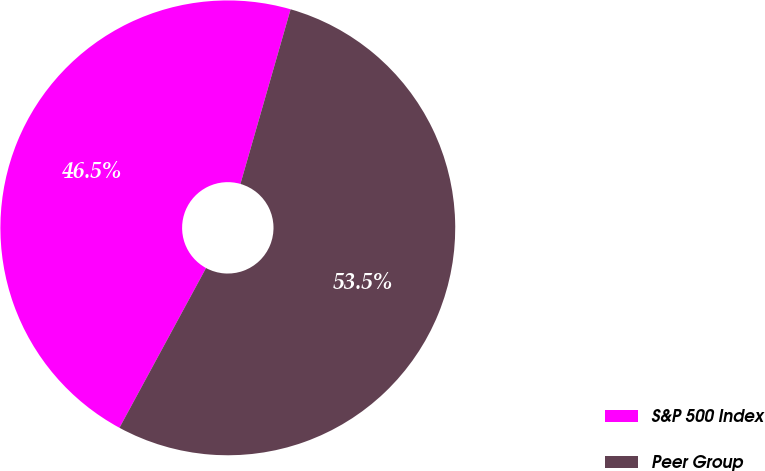Convert chart to OTSL. <chart><loc_0><loc_0><loc_500><loc_500><pie_chart><fcel>S&P 500 Index<fcel>Peer Group<nl><fcel>46.55%<fcel>53.45%<nl></chart> 